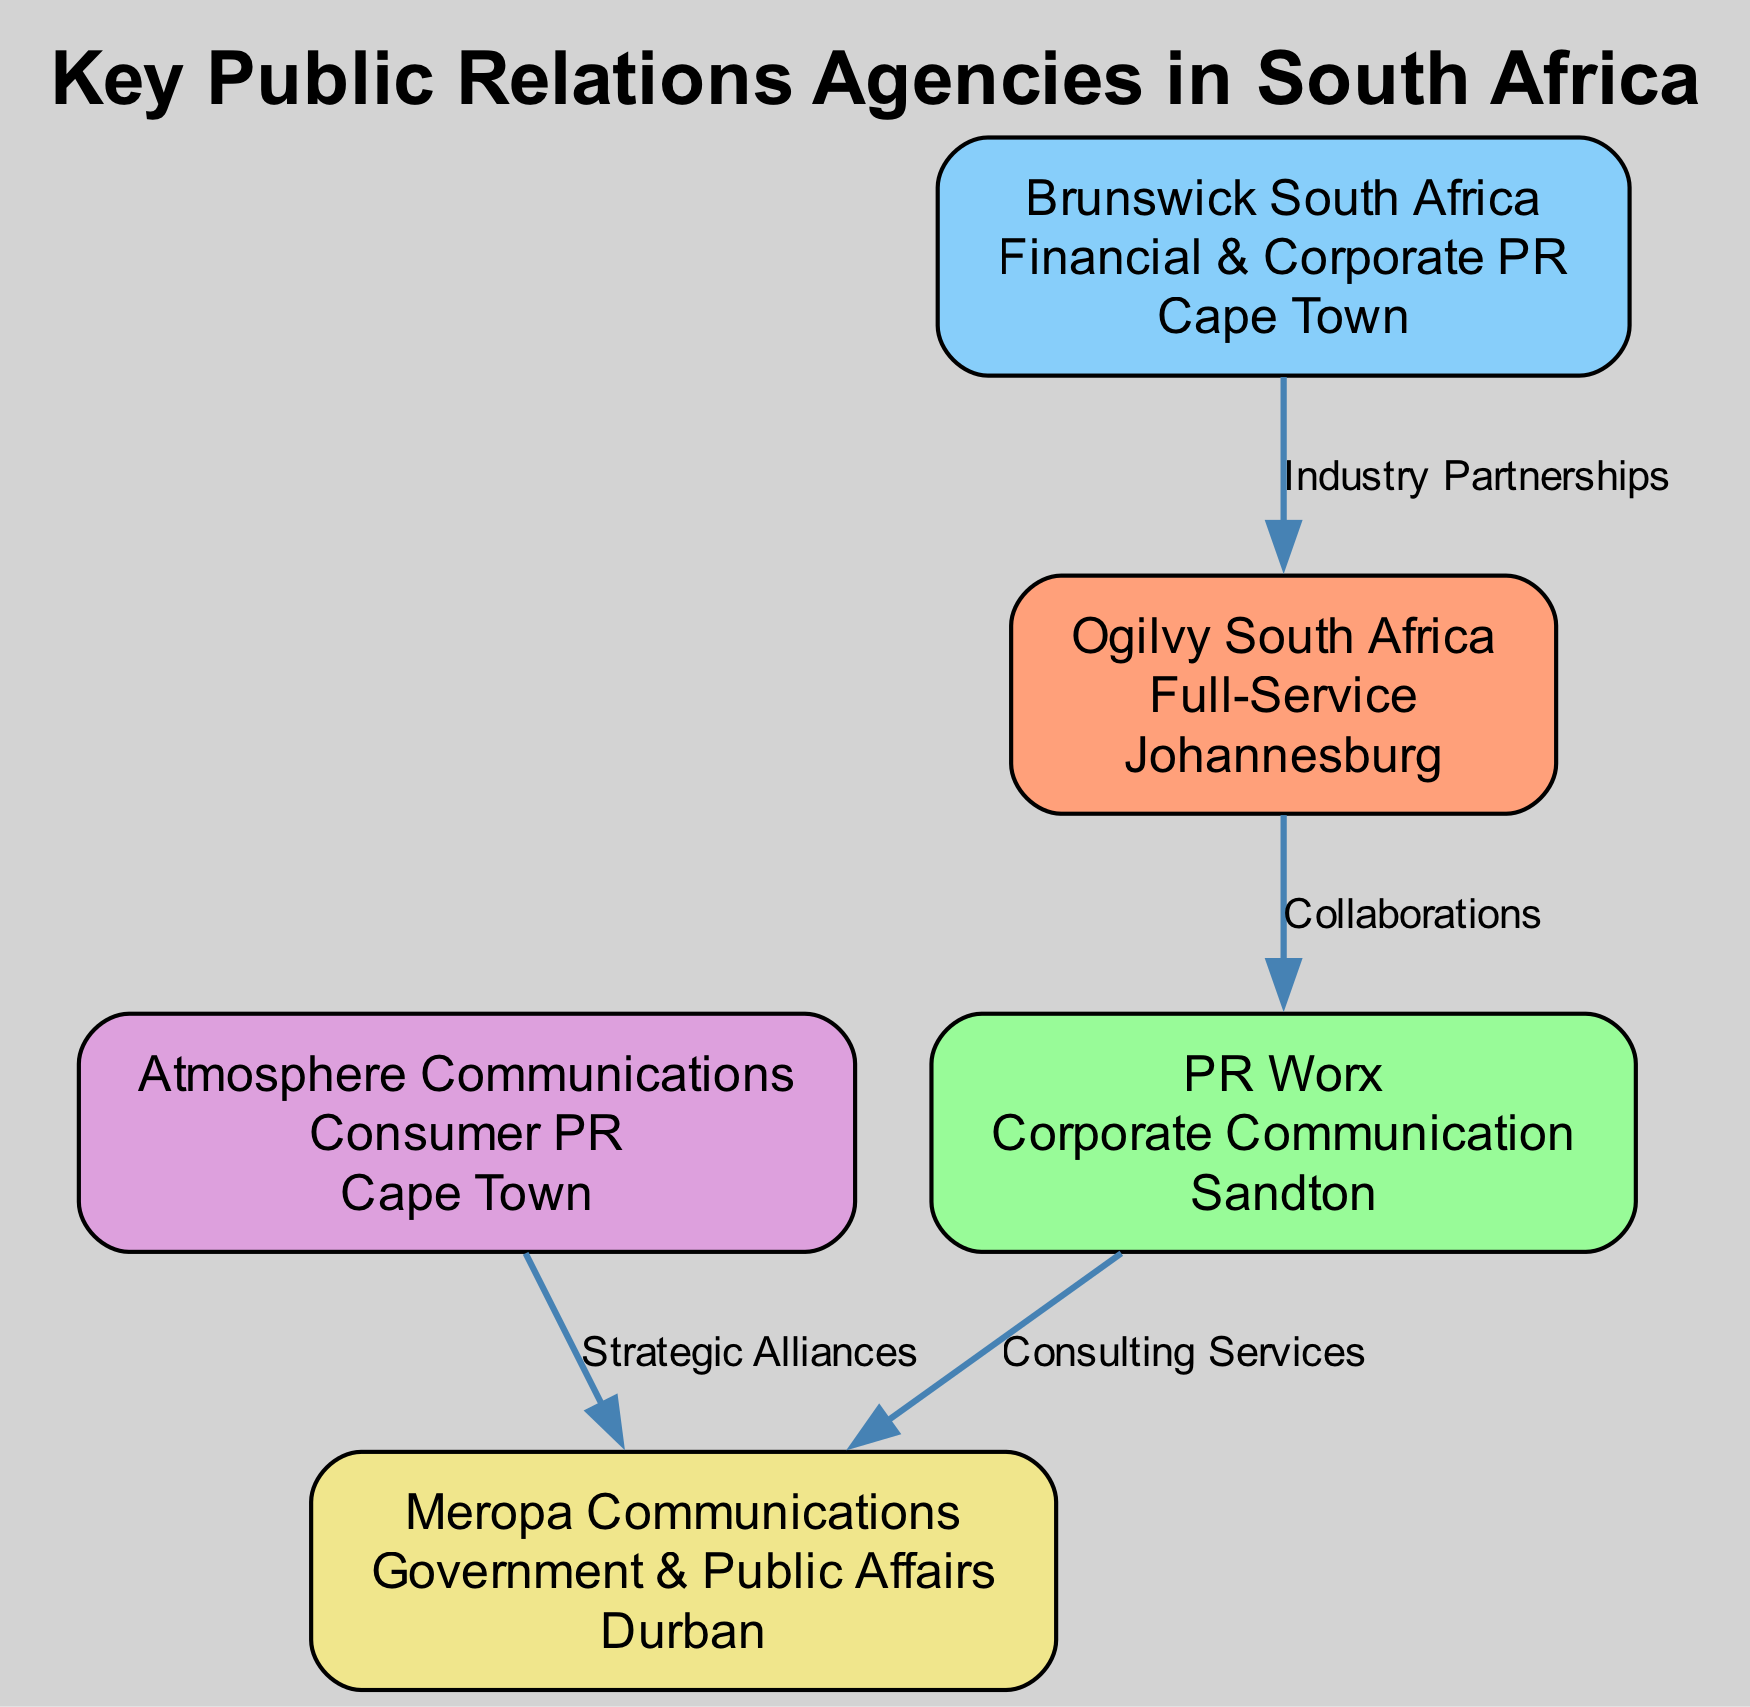What is the headquarters of Ogilvy South Africa? The diagram states that Ogilvy South Africa's headquarters is located in Johannesburg.
Answer: Johannesburg How many public relations agencies are shown in the diagram? By counting the nodes listed in the diagram, there are five public relations agencies in total: Ogilvy South Africa, PR Worx, Brunswick South Africa, Atmosphere Communications, and Meropa Communications.
Answer: 5 What sector does Meropa Communications specialize in? According to the information in the diagram, Meropa Communications specializes in Government & Public Affairs.
Answer: Government & Public Affairs Which agency is in Cape Town and specializes in Financial & Corporate PR? The diagram indicates that Brunswick South Africa is located in Cape Town and specializes in Financial & Corporate PR.
Answer: Brunswick South Africa What type of relationship exists between PR Worx and Meropa Communications? The diagram specifies that the relationship between PR Worx and Meropa Communications is Consulting Services.
Answer: Consulting Services Which node has the most connections to other agencies? By analyzing the edges in the diagram, it becomes clear that Ogilvy South Africa has two connections (to PR Worx and Brunswick South Africa) while others have fewer, making Ogilvy South Africa the most connected agency.
Answer: Ogilvy South Africa Which agency is involved in Strategic Alliances? The diagram shows that Atmosphere Communications has a connection indicating a Strategic Alliance with Meropa Communications.
Answer: Atmosphere Communications Which agency combines being a full-service provider and is headquartered in Johannesburg? The diagram reveals that Ogilvy South Africa is classified as a Full-Service agency and is based in Johannesburg.
Answer: Ogilvy South Africa What sector does PR Worx operate in? Based on the diagram, PR Worx is involved in the sector of Corporate Communication.
Answer: Corporate Communication 